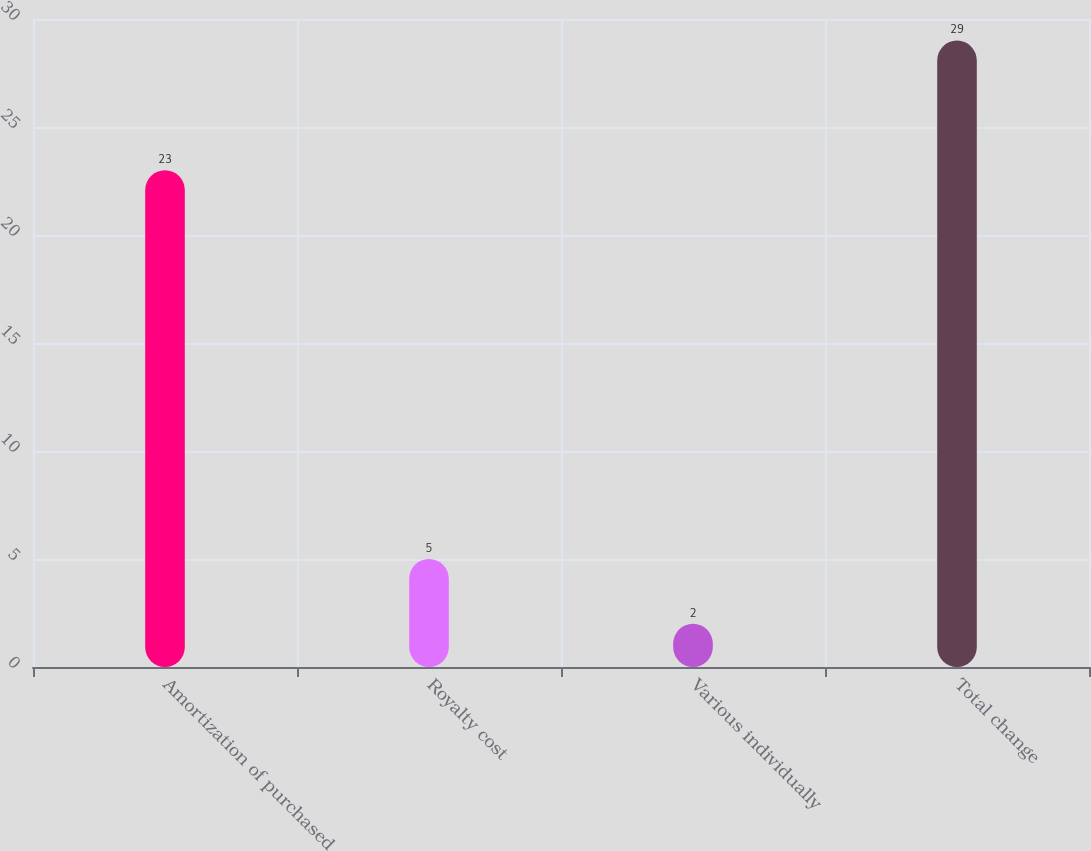<chart> <loc_0><loc_0><loc_500><loc_500><bar_chart><fcel>Amortization of purchased<fcel>Royalty cost<fcel>Various individually<fcel>Total change<nl><fcel>23<fcel>5<fcel>2<fcel>29<nl></chart> 